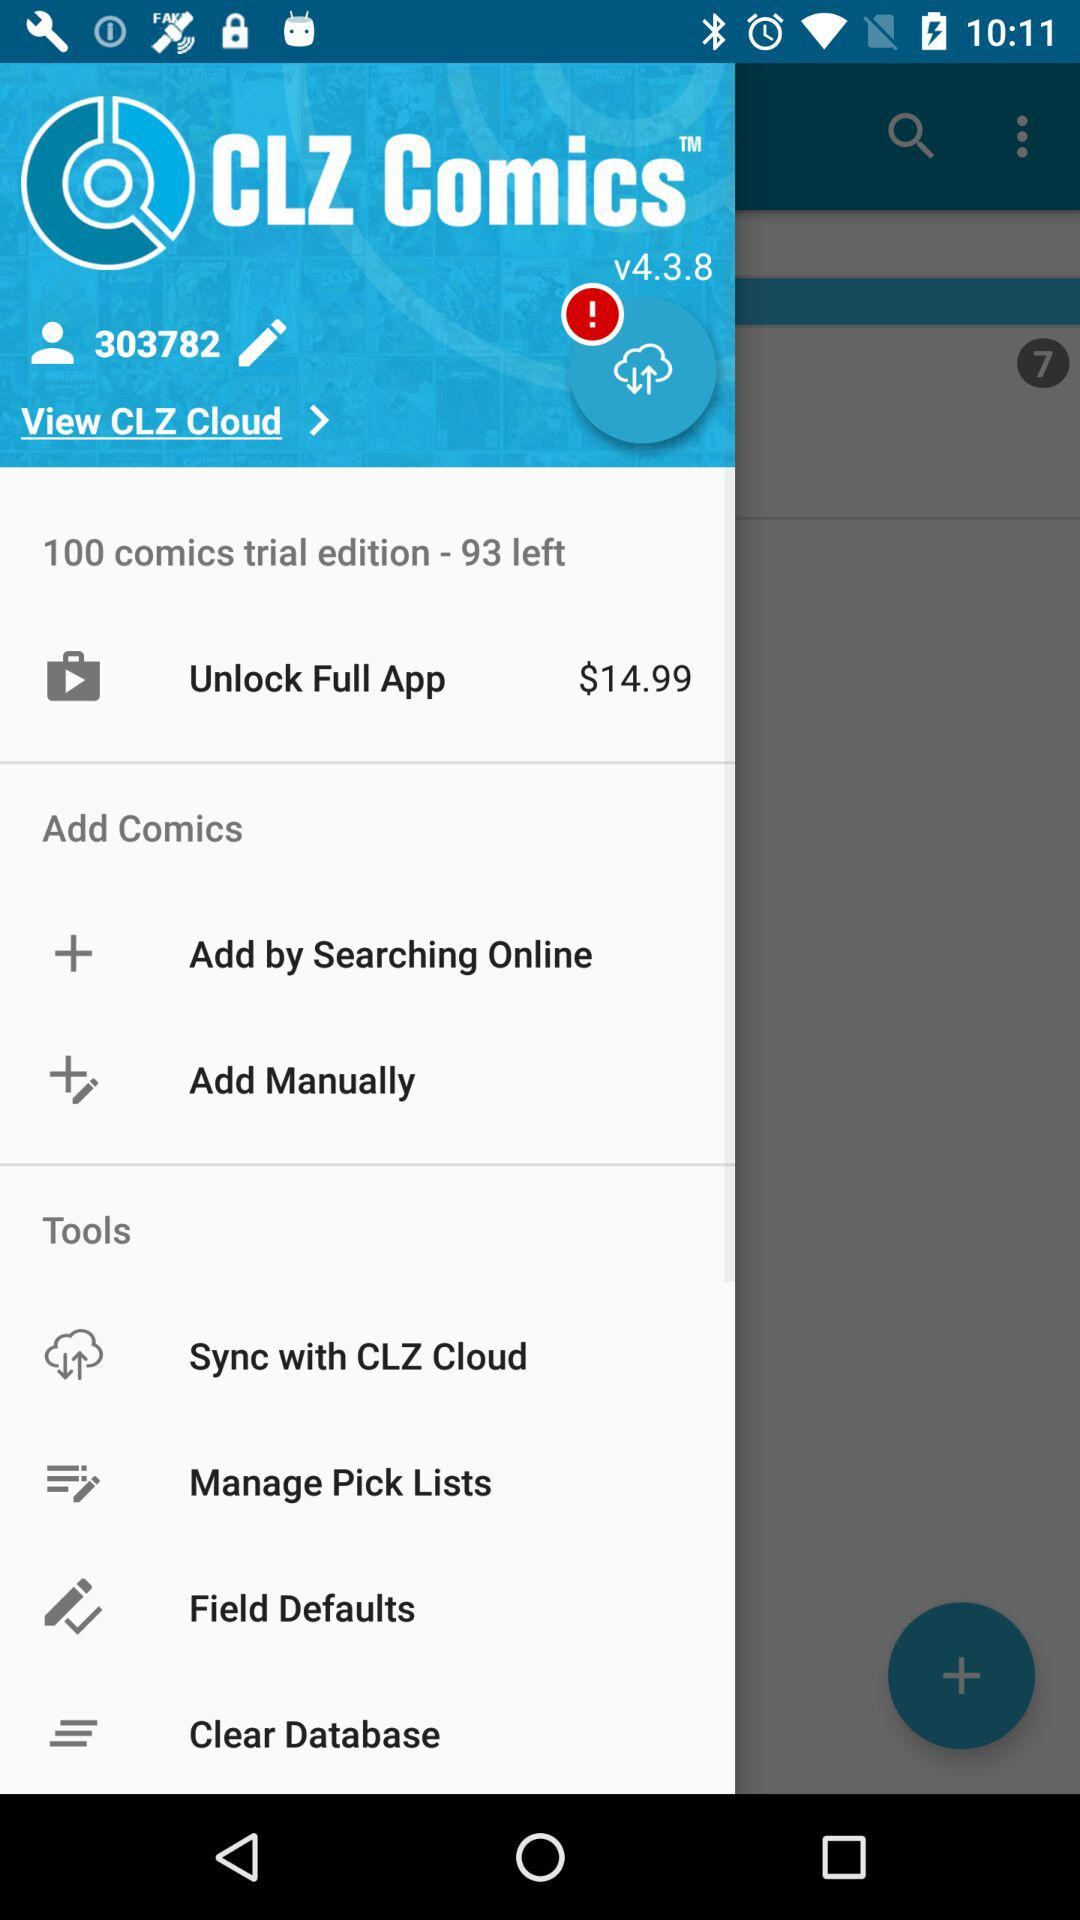How many comics are left in the trial edition? The number of comics that are left in the trial edition is 93. 